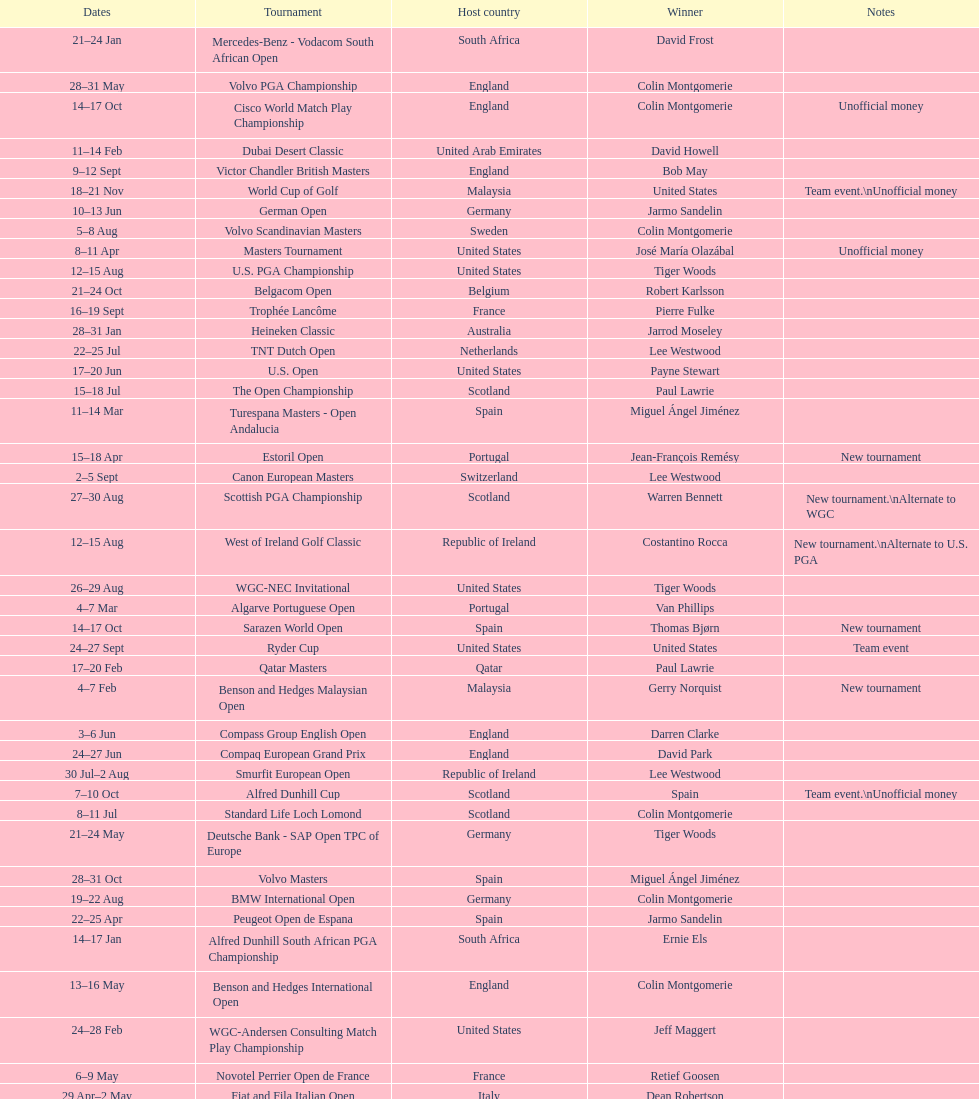What was the country listed the first time there was a new tournament? Malaysia. 